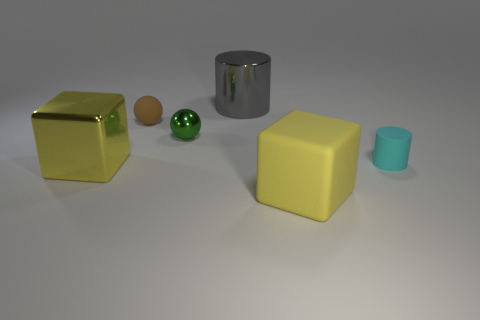There is another block that is the same color as the metallic cube; what is its size?
Your answer should be very brief. Large. What number of large shiny things have the same color as the large rubber thing?
Offer a very short reply. 1. There is a matte object that is in front of the cyan thing; is it the same size as the green sphere left of the large cylinder?
Provide a short and direct response. No. Is there a big yellow block that has the same material as the gray object?
Your response must be concise. Yes. There is a yellow metal thing; what shape is it?
Provide a short and direct response. Cube. The large shiny object that is on the left side of the big metallic object right of the small brown sphere is what shape?
Your response must be concise. Cube. There is a yellow thing that is in front of the block that is to the left of the small brown rubber object; what is its size?
Offer a very short reply. Large. Are any large gray metallic things visible?
Keep it short and to the point. Yes. There is a tiny object that is to the left of the metal ball; how many small green things are on the left side of it?
Keep it short and to the point. 0. What shape is the small rubber thing behind the tiny metallic sphere?
Your answer should be compact. Sphere. 